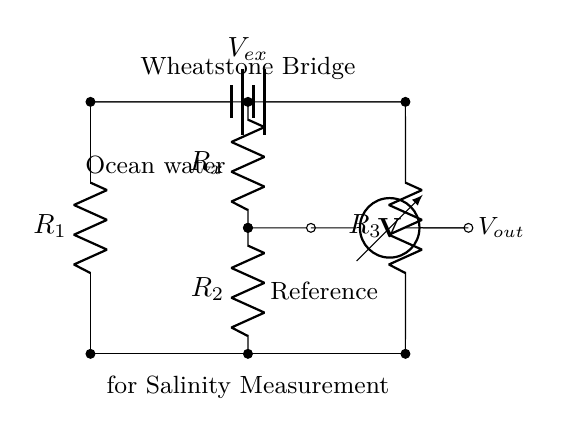What is the role of R2 in the Wheatstone bridge? R2 is used as one of the resistive elements in the bridge, allowing for the measurement of the resistance of the unknown component R_x against the known resistance.
Answer: Resistor What does V_ex represent in the circuit? V_ex represents the external voltage supply applied across the Wheatstone bridge, which powers the circuit and enables the measurement of salinity by detecting voltage changes corresponding to resistance changes.
Answer: External voltage How many resistors are there in this Wheatstone bridge circuit? The circuit diagram shows four resistors: R1, R2, R3, and R_x. Each is part of the bridge configuration used to determine the salinity level through resistance measurements.
Answer: Four What is the purpose of the voltmeter in the circuit? The voltmeter measures the output voltage (V_out) across the bridge, which changes based on the balance of resistances, allowing for the calculation of salinity levels based on these voltage variations.
Answer: Measurement If R1 equals R3, what happens to V_out? If R1 equals R3 and R2 equals R_x, the bridge is balanced, resulting in zero voltage output across the voltmeter. This means salinity levels are at a desired reference point.
Answer: Zero Which component is connected to the ocean water? The component that interacts with the ocean water is R_x, which represents the unknown resistance related to the salinity measurement, while the reference resistor is R2.
Answer: R_x What is the significance of the Wheatstone bridge configuration in this context? The Wheatstone bridge configuration is significant as it allows for precise measurement of small changes in resistance, which directly relate to salinity levels, enabling environmental monitoring.
Answer: Precision measurement 